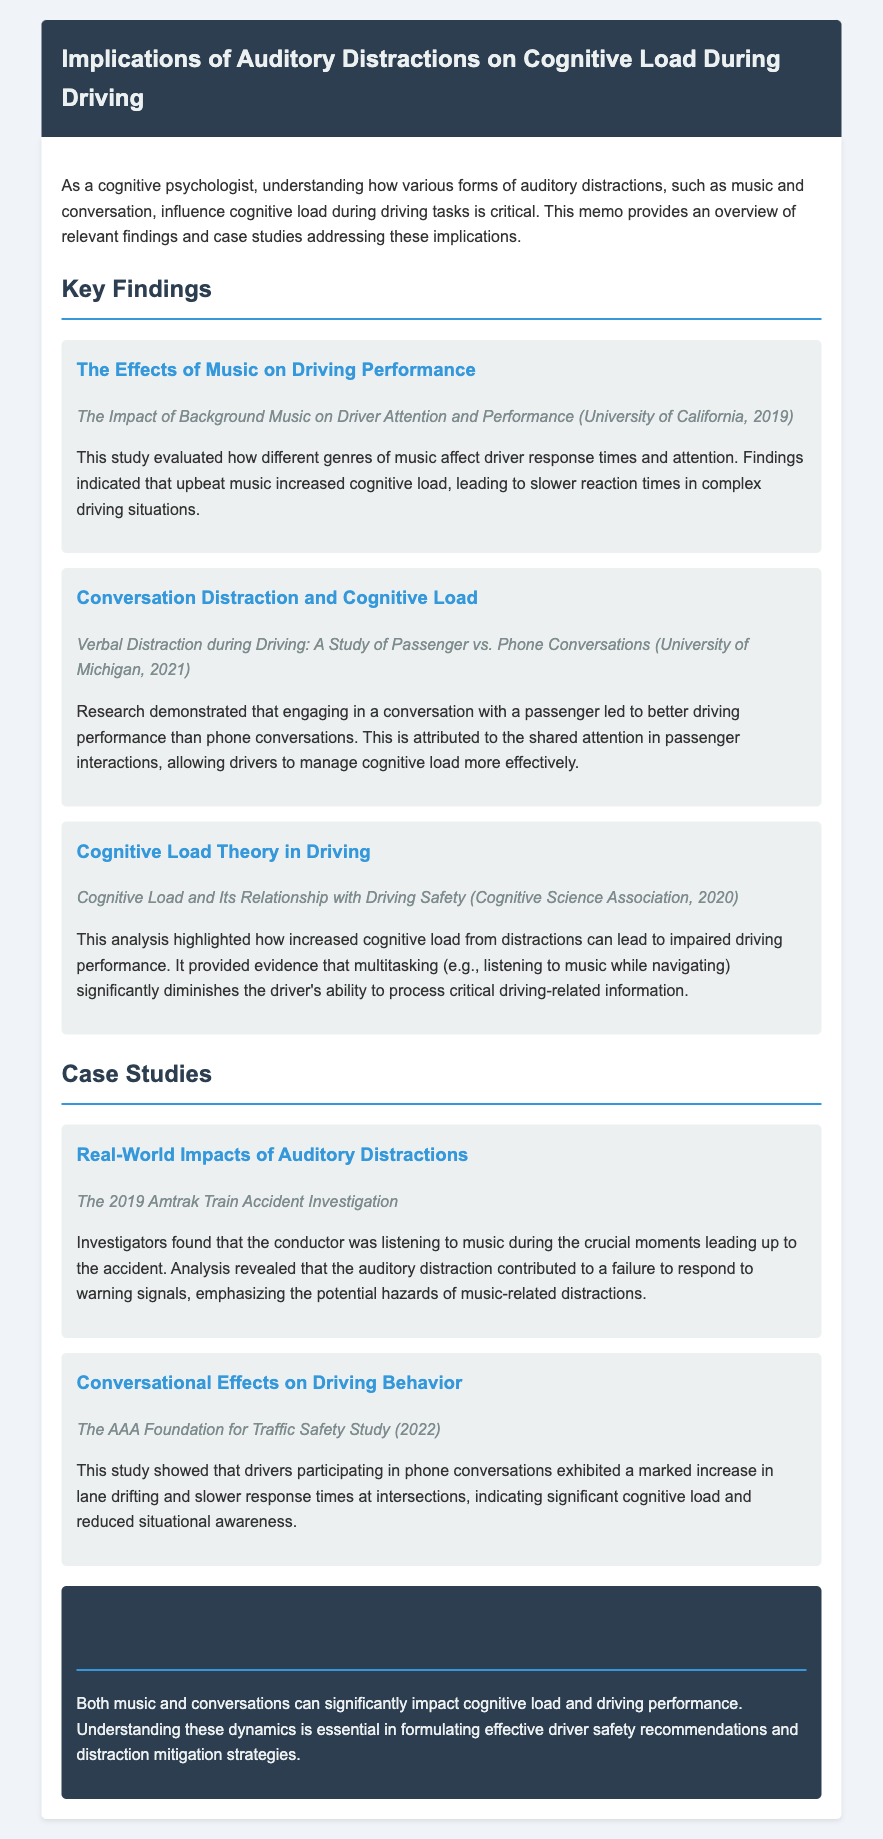What is the title of the memo? The title of the memo is provided at the beginning of the document.
Answer: Implications of Auditory Distractions on Cognitive Load During Driving Which university conducted the study on background music and driving performance? The university mentioned in the study about the effects of background music is included in the findings section.
Answer: University of California What year was the study on conversational distraction conducted? The year of the study on verbal distraction during driving is specified in the document.
Answer: 2021 What does the study by the Cognitive Science Association analyze? The analysis mentioned in the findings section highlights a specific aspect of cognitive load concerning driving safety.
Answer: Cognitive Load and Its Relationship with Driving Safety What were the consequences of the Amtrak train accident related to auditory distractions? The findings related to the Amtrak train accident detail a particular situation of distraction leading to an incident.
Answer: Conductor listening to music What is the primary conclusion regarding music and conversations on driving performance? The conclusion summarizes the overall impact of auditory distractions outlined in the memo.
Answer: Significantly impact cognitive load and driving performance How did phone conversations influence drivers according to the AAA Foundation study? The study from the AAA Foundation describes the effects of phone conversations on specific driving behaviors.
Answer: Marked increase in lane drifting What genre of music led to slower reaction times in drivers? The findings on the impact of background music specify certain characteristics of the music affecting cognitive load.
Answer: Upbeat music 